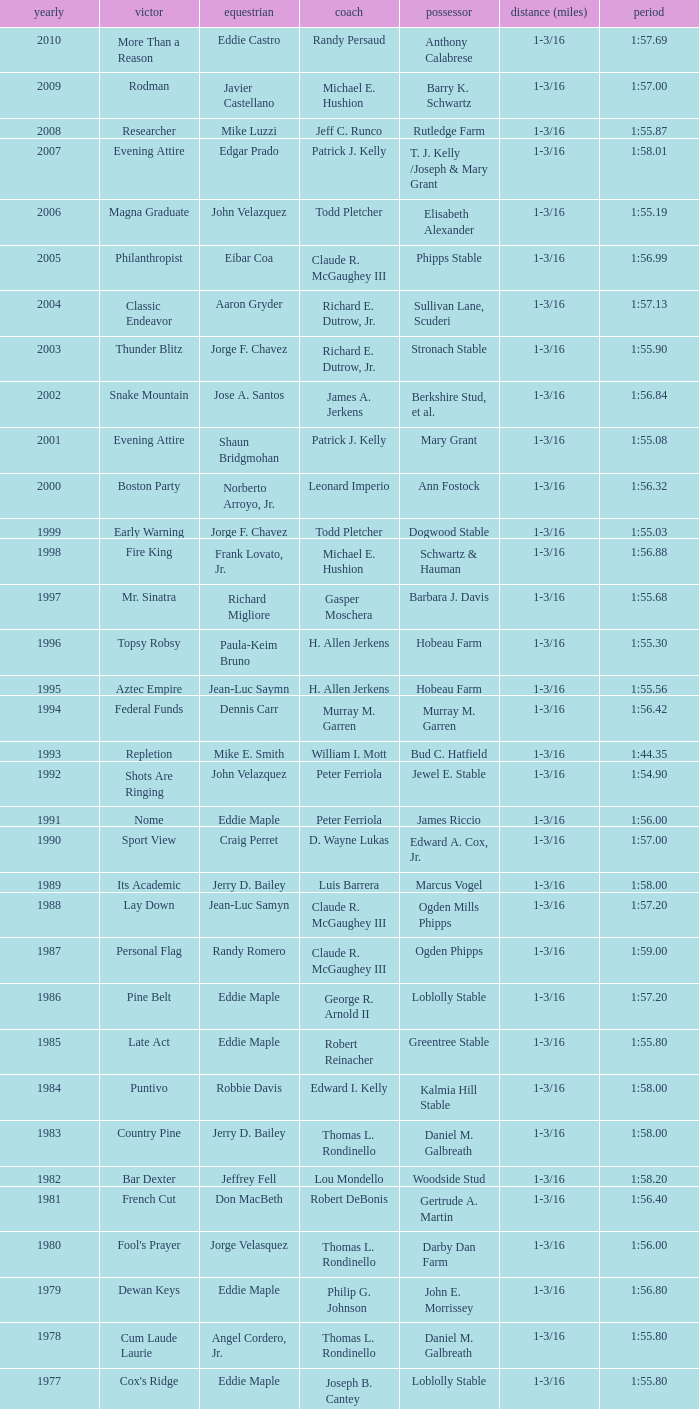What horse won with a trainer of "no race"? No Race, No Race, No Race, No Race. 